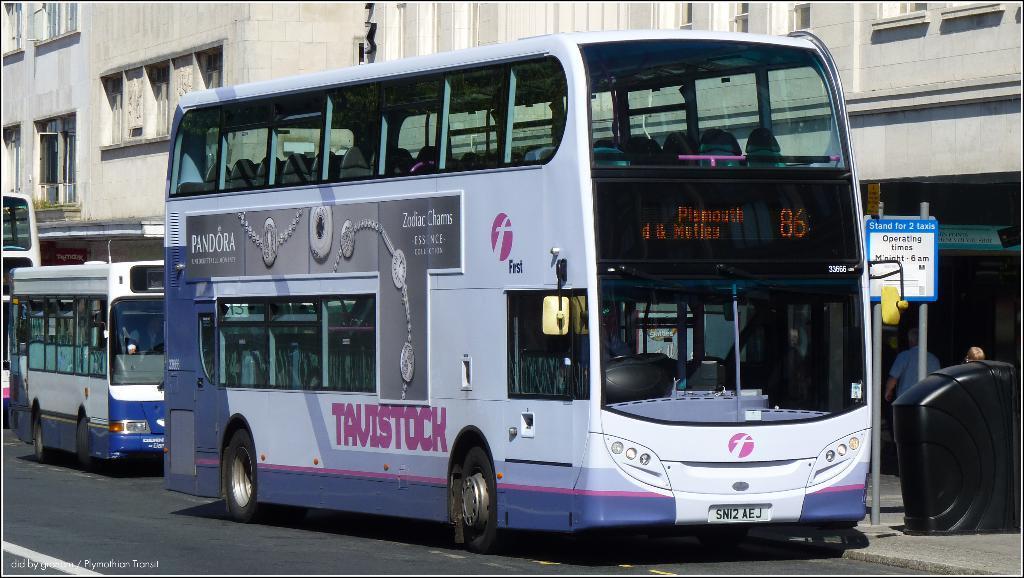In one or two sentences, can you explain what this image depicts? Here in this picture we can see buses present on the road over there and beside that we can see buildings present and we can see windows present on it over there and we can also see sign boards present here and there and we can also see people standing here and there. 